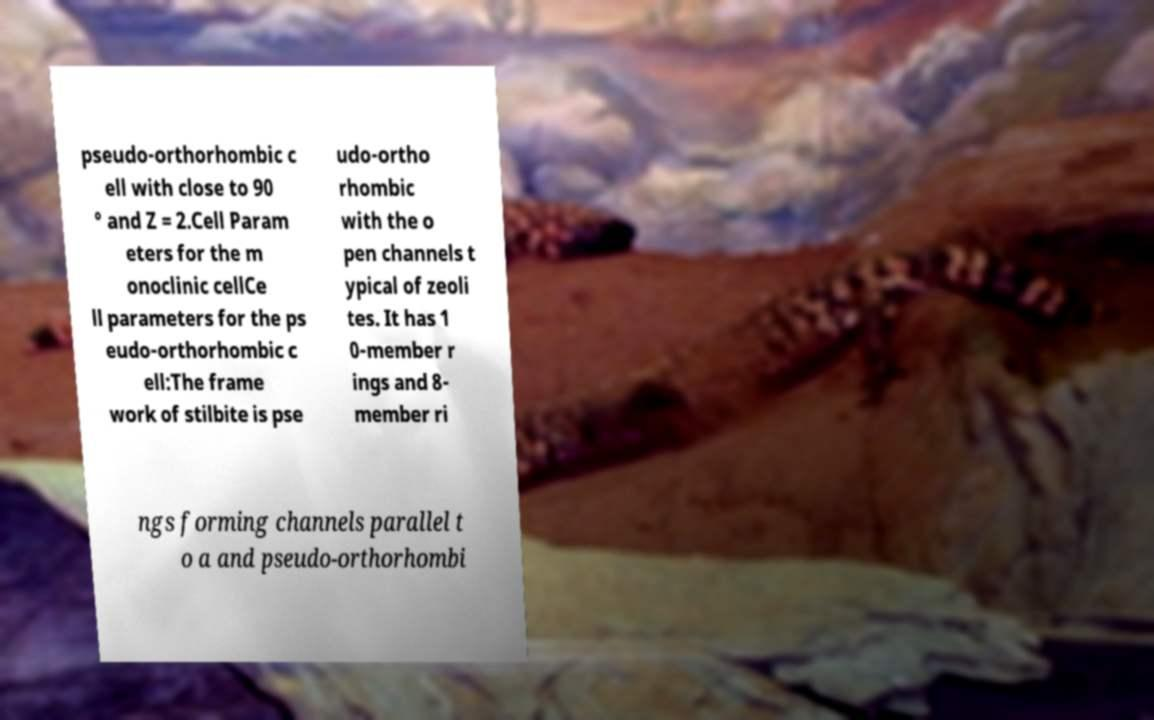For documentation purposes, I need the text within this image transcribed. Could you provide that? pseudo-orthorhombic c ell with close to 90 ° and Z = 2.Cell Param eters for the m onoclinic cellCe ll parameters for the ps eudo-orthorhombic c ell:The frame work of stilbite is pse udo-ortho rhombic with the o pen channels t ypical of zeoli tes. It has 1 0-member r ings and 8- member ri ngs forming channels parallel t o a and pseudo-orthorhombi 